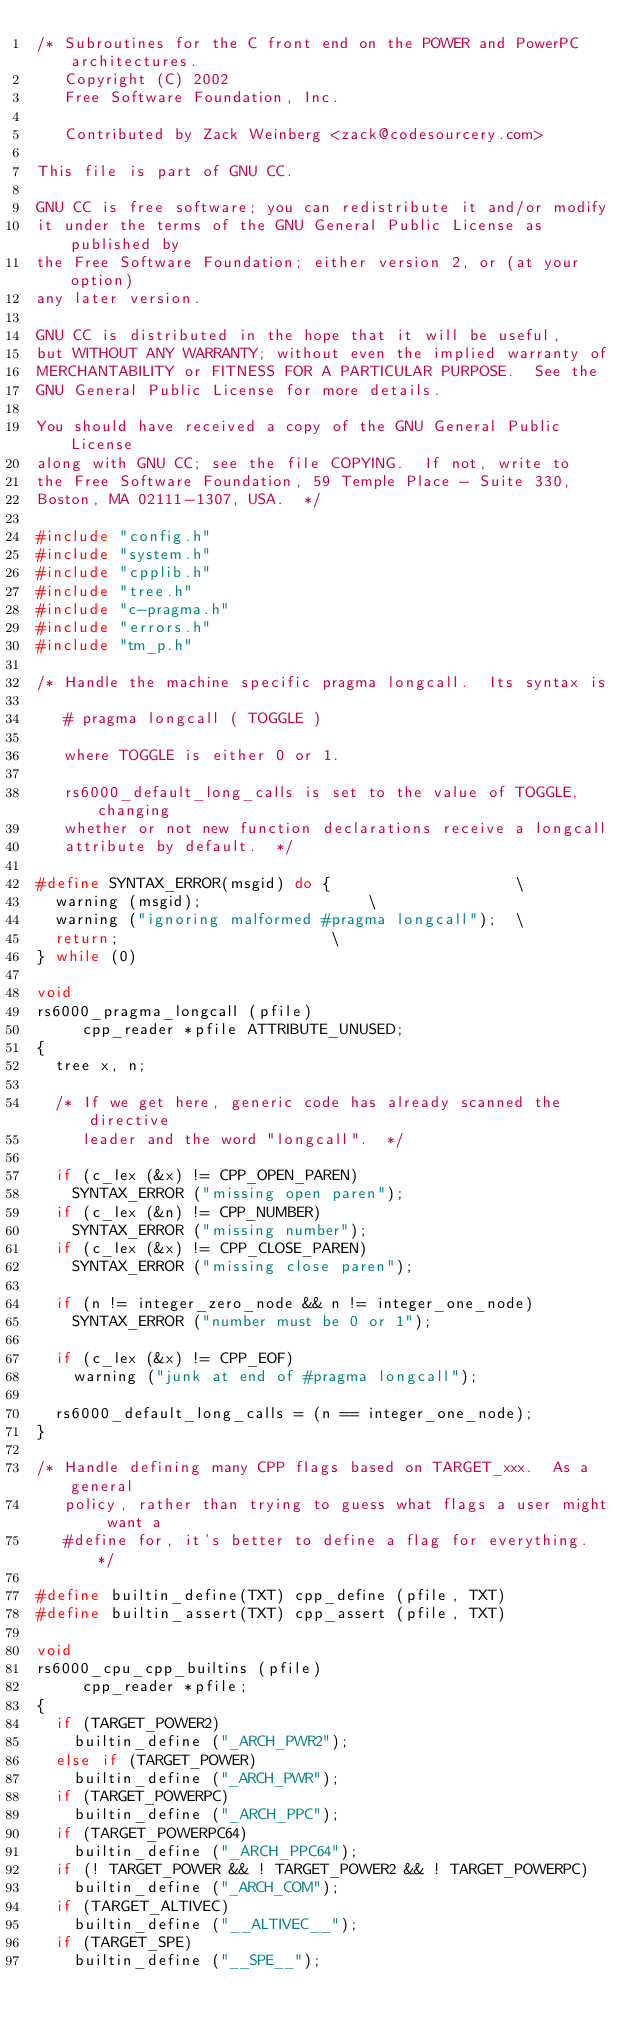<code> <loc_0><loc_0><loc_500><loc_500><_C_>/* Subroutines for the C front end on the POWER and PowerPC architectures.
   Copyright (C) 2002
   Free Software Foundation, Inc.

   Contributed by Zack Weinberg <zack@codesourcery.com>

This file is part of GNU CC.

GNU CC is free software; you can redistribute it and/or modify
it under the terms of the GNU General Public License as published by
the Free Software Foundation; either version 2, or (at your option)
any later version.

GNU CC is distributed in the hope that it will be useful,
but WITHOUT ANY WARRANTY; without even the implied warranty of
MERCHANTABILITY or FITNESS FOR A PARTICULAR PURPOSE.  See the
GNU General Public License for more details.

You should have received a copy of the GNU General Public License
along with GNU CC; see the file COPYING.  If not, write to
the Free Software Foundation, 59 Temple Place - Suite 330,
Boston, MA 02111-1307, USA.  */

#include "config.h"
#include "system.h"
#include "cpplib.h"
#include "tree.h"
#include "c-pragma.h"
#include "errors.h"
#include "tm_p.h"

/* Handle the machine specific pragma longcall.  Its syntax is

   # pragma longcall ( TOGGLE )

   where TOGGLE is either 0 or 1.

   rs6000_default_long_calls is set to the value of TOGGLE, changing
   whether or not new function declarations receive a longcall
   attribute by default.  */

#define SYNTAX_ERROR(msgid) do {					\
  warning (msgid);					\
  warning ("ignoring malformed #pragma longcall");	\
  return;						\
} while (0)

void
rs6000_pragma_longcall (pfile)
     cpp_reader *pfile ATTRIBUTE_UNUSED;
{
  tree x, n;

  /* If we get here, generic code has already scanned the directive
     leader and the word "longcall".  */

  if (c_lex (&x) != CPP_OPEN_PAREN)
    SYNTAX_ERROR ("missing open paren");
  if (c_lex (&n) != CPP_NUMBER)
    SYNTAX_ERROR ("missing number");
  if (c_lex (&x) != CPP_CLOSE_PAREN)
    SYNTAX_ERROR ("missing close paren");

  if (n != integer_zero_node && n != integer_one_node)
    SYNTAX_ERROR ("number must be 0 or 1");

  if (c_lex (&x) != CPP_EOF)
    warning ("junk at end of #pragma longcall");

  rs6000_default_long_calls = (n == integer_one_node);
}

/* Handle defining many CPP flags based on TARGET_xxx.  As a general
   policy, rather than trying to guess what flags a user might want a
   #define for, it's better to define a flag for everything.  */

#define builtin_define(TXT) cpp_define (pfile, TXT)
#define builtin_assert(TXT) cpp_assert (pfile, TXT)

void
rs6000_cpu_cpp_builtins (pfile)
     cpp_reader *pfile;
{
  if (TARGET_POWER2)
    builtin_define ("_ARCH_PWR2");
  else if (TARGET_POWER)
    builtin_define ("_ARCH_PWR");
  if (TARGET_POWERPC)
    builtin_define ("_ARCH_PPC");
  if (TARGET_POWERPC64)
    builtin_define ("_ARCH_PPC64");
  if (! TARGET_POWER && ! TARGET_POWER2 && ! TARGET_POWERPC)
    builtin_define ("_ARCH_COM");
  if (TARGET_ALTIVEC)
    builtin_define ("__ALTIVEC__");
  if (TARGET_SPE)
    builtin_define ("__SPE__");</code> 